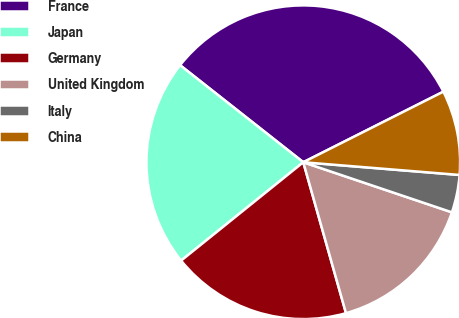Convert chart. <chart><loc_0><loc_0><loc_500><loc_500><pie_chart><fcel>France<fcel>Japan<fcel>Germany<fcel>United Kingdom<fcel>Italy<fcel>China<nl><fcel>31.96%<fcel>21.41%<fcel>18.6%<fcel>15.44%<fcel>3.88%<fcel>8.72%<nl></chart> 